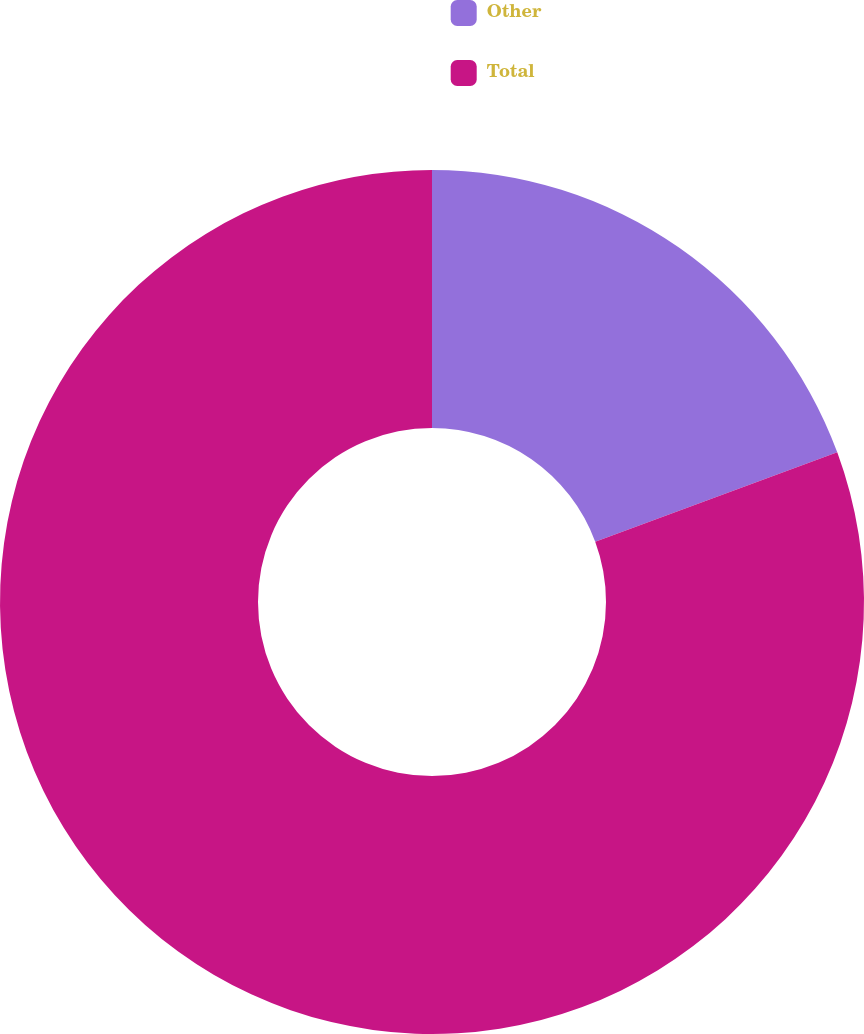<chart> <loc_0><loc_0><loc_500><loc_500><pie_chart><fcel>Other<fcel>Total<nl><fcel>19.37%<fcel>80.63%<nl></chart> 